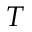<formula> <loc_0><loc_0><loc_500><loc_500>T</formula> 